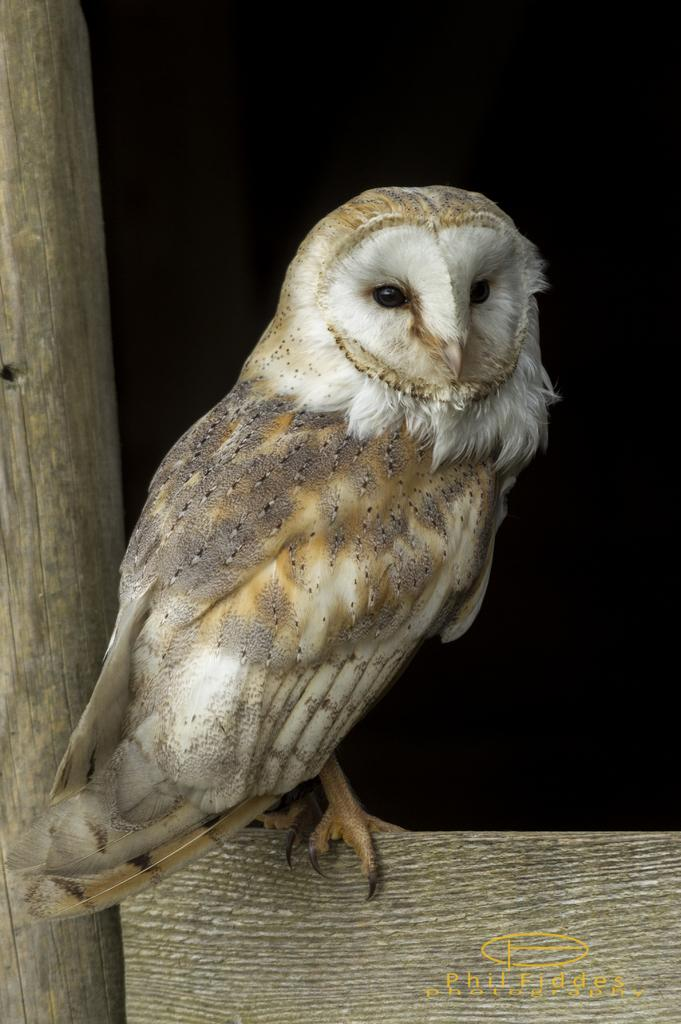What animal is present in the image? There is an owl in the image. What is the owl sitting on? The owl is on an object. Can you describe the object on the left side of the image? There is a wooden object on the left side of the image. How would you describe the overall lighting in the image? The background of the image is dark. Is there any additional information or branding present in the image? Yes, there is a watermark in the right bottom corner of the image. What type of decision is the owl making in the image? The image does not depict the owl making a decision, as it is a still image. How many pizzas are visible in the image? There are no pizzas present in the image. 